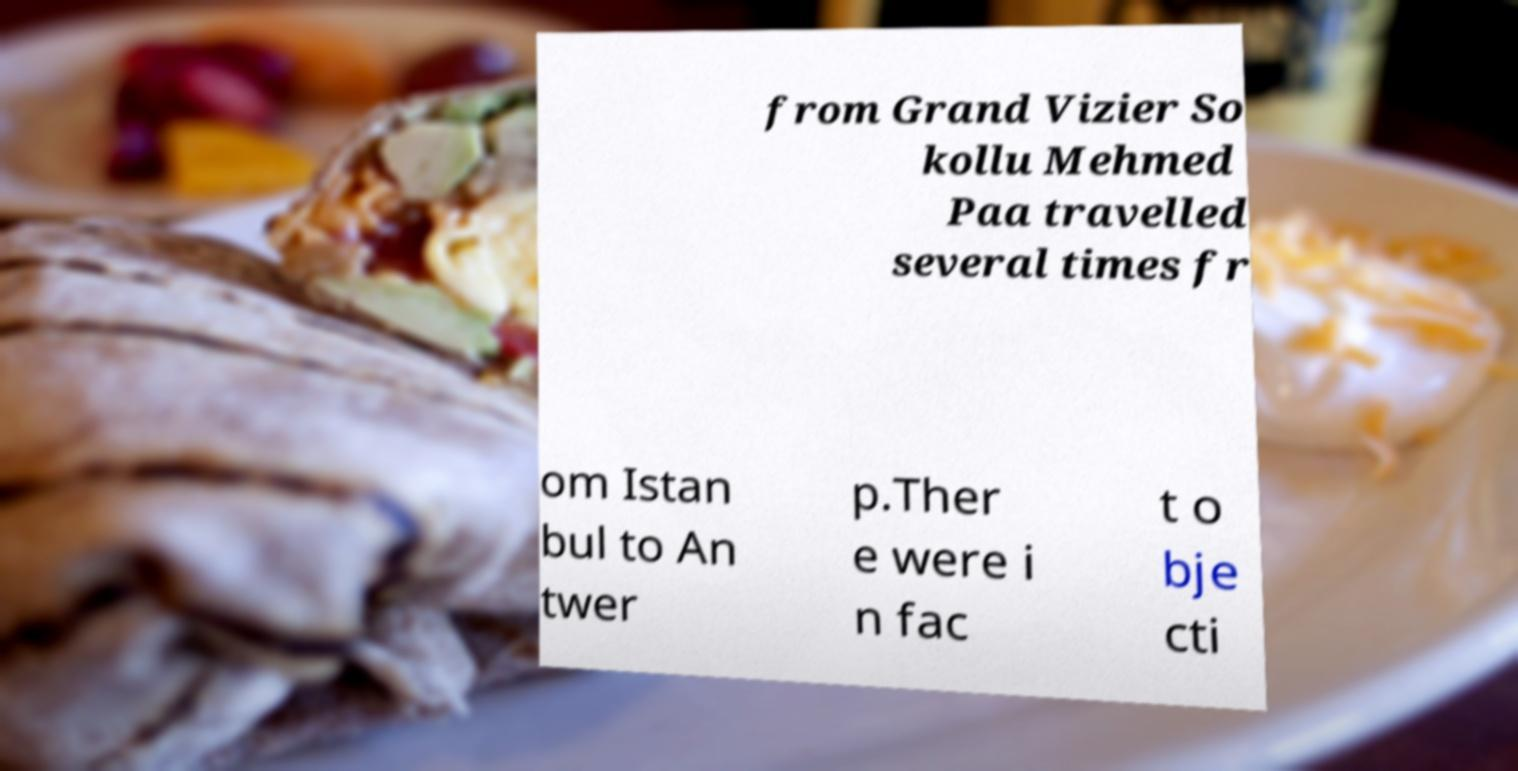For documentation purposes, I need the text within this image transcribed. Could you provide that? from Grand Vizier So kollu Mehmed Paa travelled several times fr om Istan bul to An twer p.Ther e were i n fac t o bje cti 